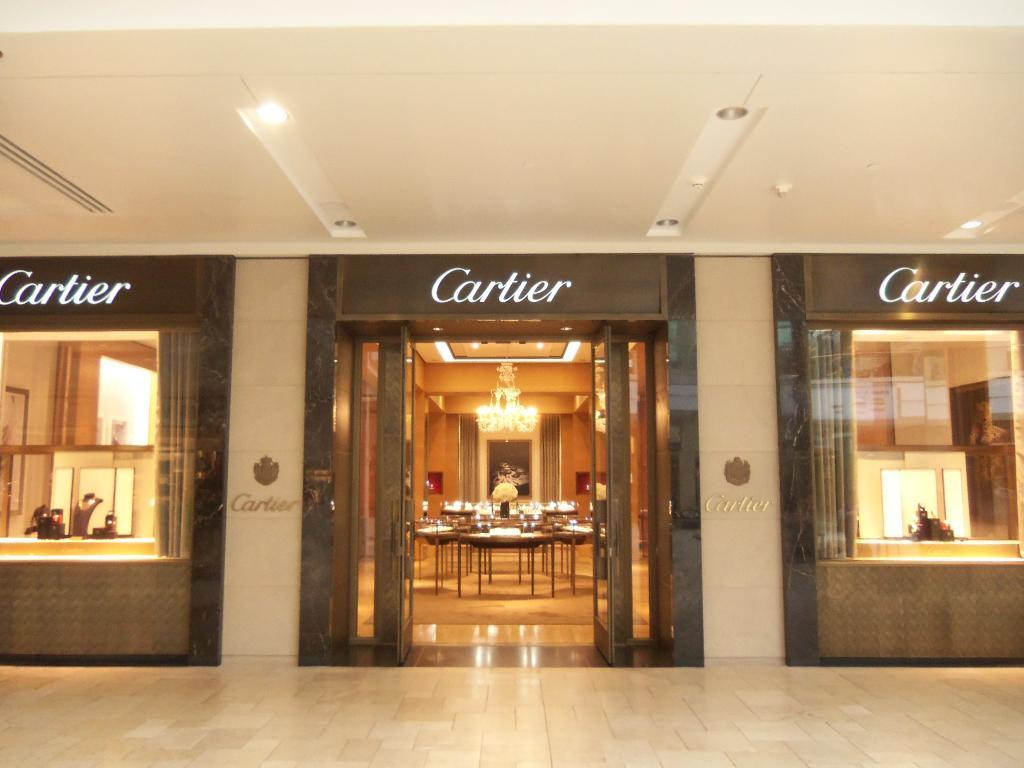What type of establishment is depicted in the image? The image appears to depict a hotel. What object can be seen in the middle of the image? There is a table in the middle of the image. What type of door is visible in the image? There is a glass door visible in the image. How many bridges can be seen in the image? There are no bridges present in the image. What type of roll is being used to open the glass door in the image? There is no roll present in the image, and the glass door does not appear to be operated by a roll. 